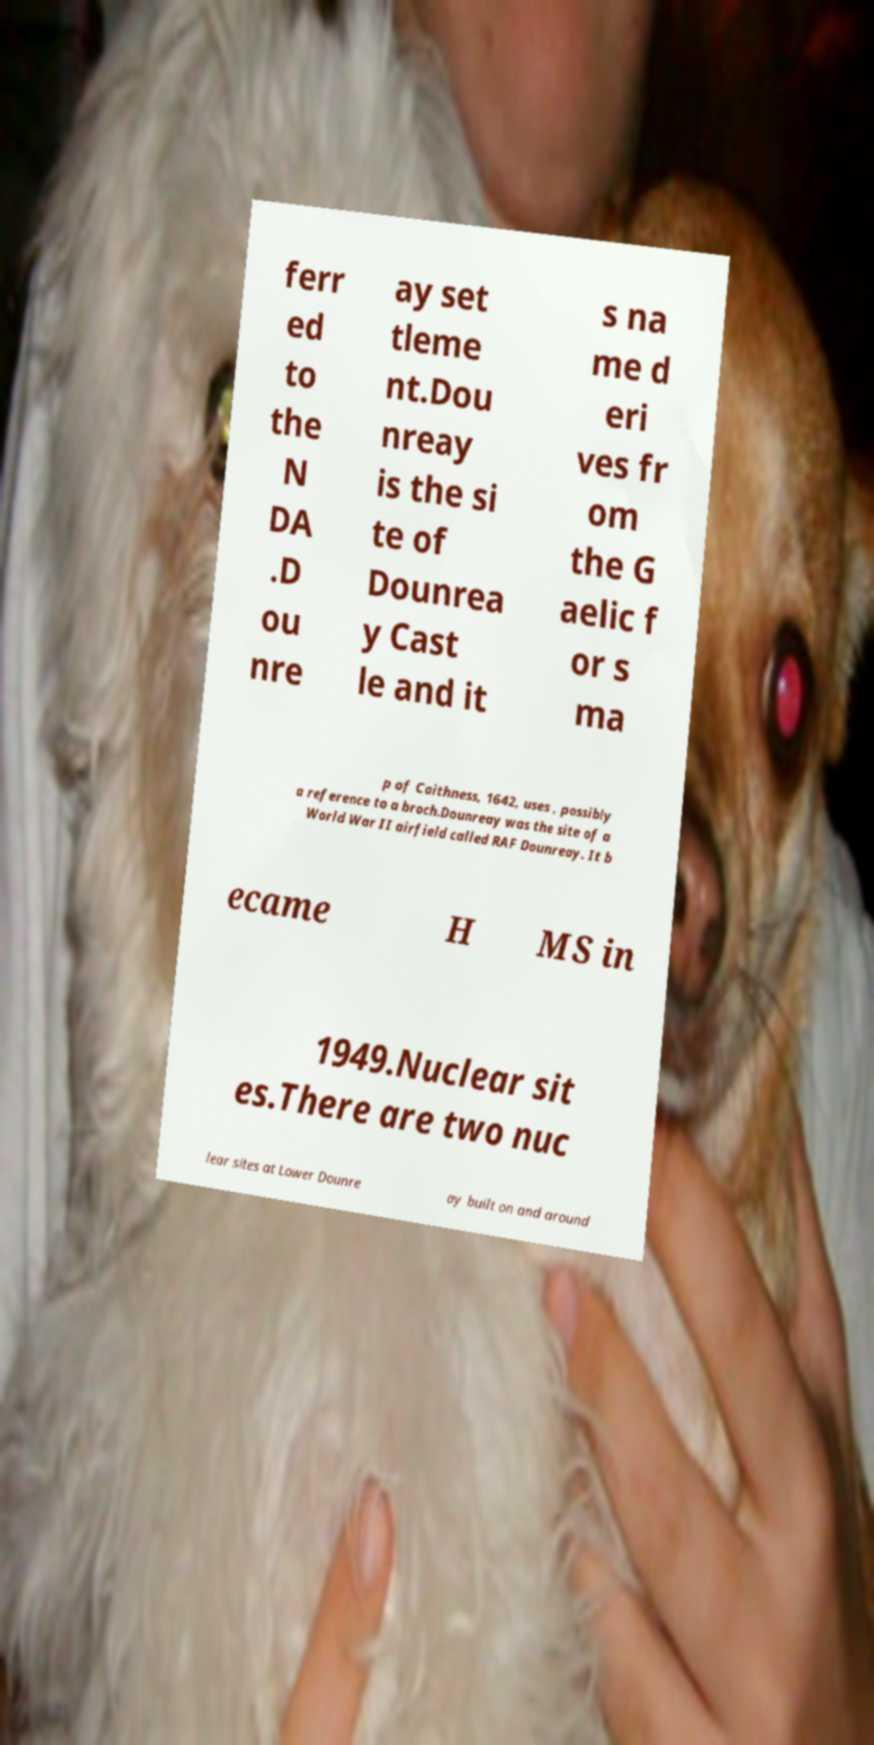For documentation purposes, I need the text within this image transcribed. Could you provide that? ferr ed to the N DA .D ou nre ay set tleme nt.Dou nreay is the si te of Dounrea y Cast le and it s na me d eri ves fr om the G aelic f or s ma p of Caithness, 1642, uses , possibly a reference to a broch.Dounreay was the site of a World War II airfield called RAF Dounreay. It b ecame H MS in 1949.Nuclear sit es.There are two nuc lear sites at Lower Dounre ay built on and around 